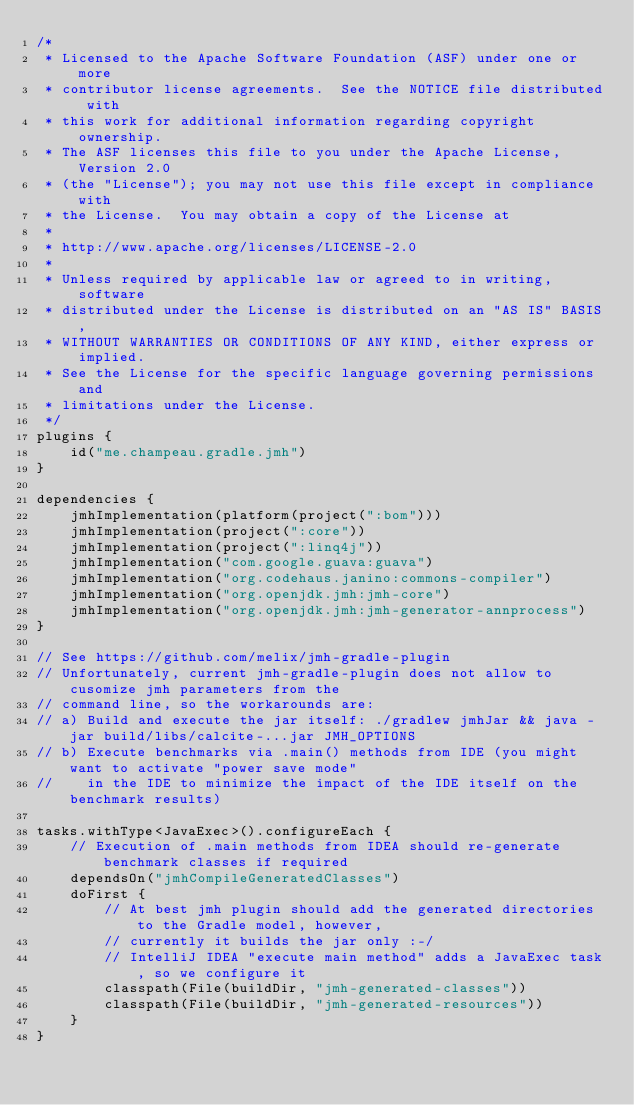<code> <loc_0><loc_0><loc_500><loc_500><_Kotlin_>/*
 * Licensed to the Apache Software Foundation (ASF) under one or more
 * contributor license agreements.  See the NOTICE file distributed with
 * this work for additional information regarding copyright ownership.
 * The ASF licenses this file to you under the Apache License, Version 2.0
 * (the "License"); you may not use this file except in compliance with
 * the License.  You may obtain a copy of the License at
 *
 * http://www.apache.org/licenses/LICENSE-2.0
 *
 * Unless required by applicable law or agreed to in writing, software
 * distributed under the License is distributed on an "AS IS" BASIS,
 * WITHOUT WARRANTIES OR CONDITIONS OF ANY KIND, either express or implied.
 * See the License for the specific language governing permissions and
 * limitations under the License.
 */
plugins {
    id("me.champeau.gradle.jmh")
}

dependencies {
    jmhImplementation(platform(project(":bom")))
    jmhImplementation(project(":core"))
    jmhImplementation(project(":linq4j"))
    jmhImplementation("com.google.guava:guava")
    jmhImplementation("org.codehaus.janino:commons-compiler")
    jmhImplementation("org.openjdk.jmh:jmh-core")
    jmhImplementation("org.openjdk.jmh:jmh-generator-annprocess")
}

// See https://github.com/melix/jmh-gradle-plugin
// Unfortunately, current jmh-gradle-plugin does not allow to cusomize jmh parameters from the
// command line, so the workarounds are:
// a) Build and execute the jar itself: ./gradlew jmhJar && java -jar build/libs/calcite-...jar JMH_OPTIONS
// b) Execute benchmarks via .main() methods from IDE (you might want to activate "power save mode"
//    in the IDE to minimize the impact of the IDE itself on the benchmark results)

tasks.withType<JavaExec>().configureEach {
    // Execution of .main methods from IDEA should re-generate benchmark classes if required
    dependsOn("jmhCompileGeneratedClasses")
    doFirst {
        // At best jmh plugin should add the generated directories to the Gradle model, however,
        // currently it builds the jar only :-/
        // IntelliJ IDEA "execute main method" adds a JavaExec task, so we configure it
        classpath(File(buildDir, "jmh-generated-classes"))
        classpath(File(buildDir, "jmh-generated-resources"))
    }
}
</code> 